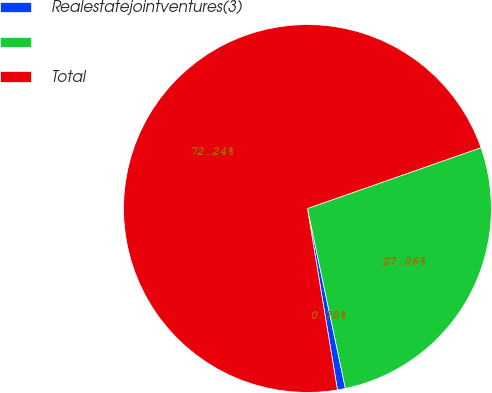Convert chart. <chart><loc_0><loc_0><loc_500><loc_500><pie_chart><fcel>Realestatejointventures(3)<fcel>Unnamed: 1<fcel>Total<nl><fcel>0.7%<fcel>27.06%<fcel>72.24%<nl></chart> 